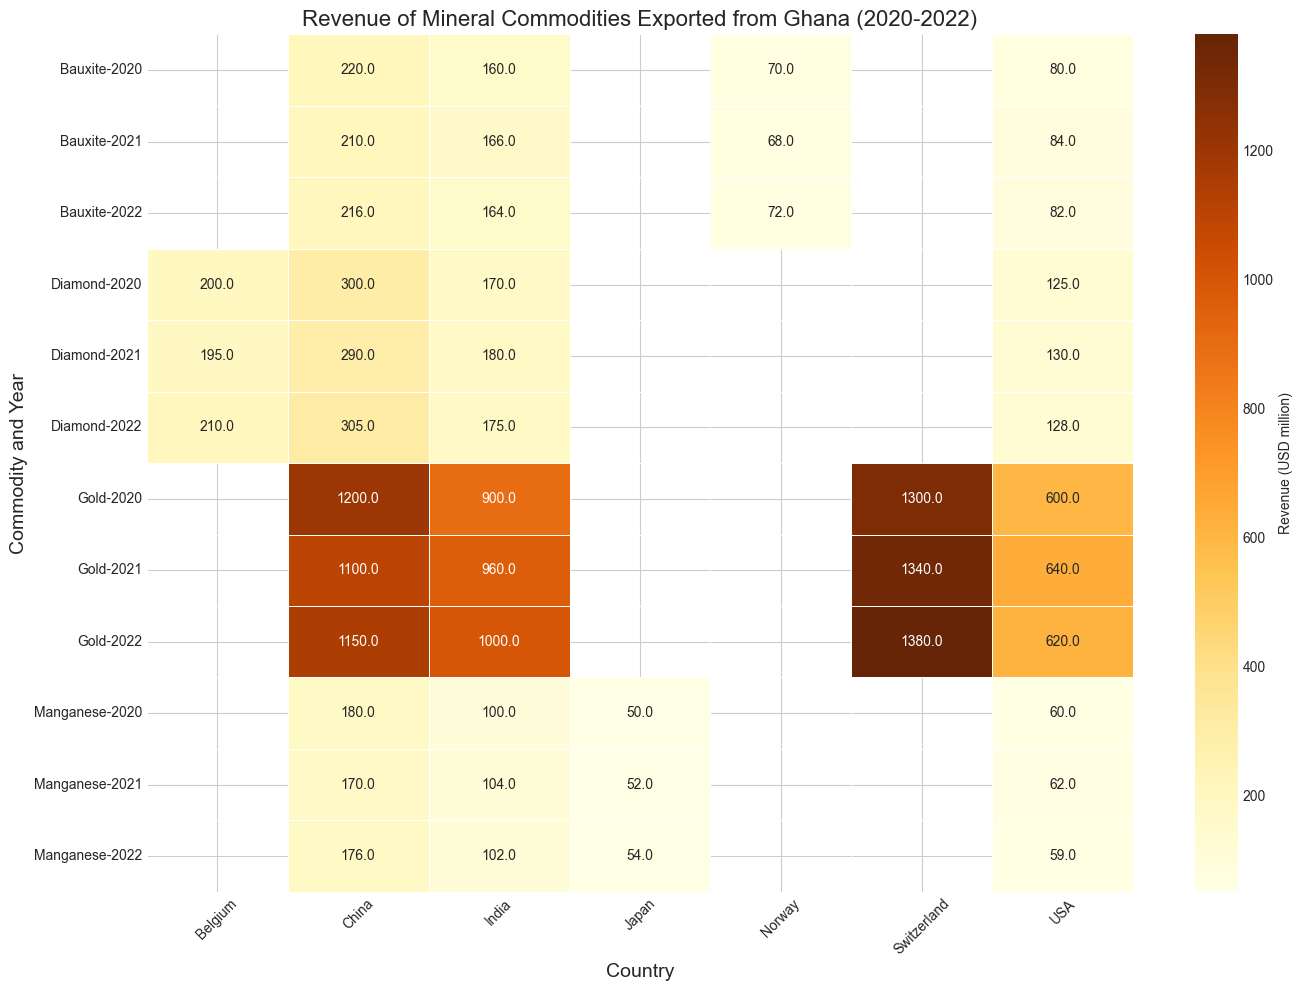What's the revenue for Gold exported to Switzerland in 2021? Locate the cell for "Gold" in the row labeled "2021," and then look under the column for "Switzerland." The value is 1340 (USD million).
Answer: 1340 (USD million) Which country received the highest revenue from Diamond exports in 2022? Locate the row for "Diamond" in the year 2022 and compare the cells under each country. The highest value is 305 (USD million) for China.
Answer: China What is the average revenue from Gold exports to the USA over the three years? Sum the values for Gold exports to the USA (600 + 640 + 620) and divide by the number of years (3). The sum is 1860, and 1860/3 is 620 (USD million).
Answer: 620 (USD million) How does the revenue from Bauxite exports to India in 2020 compare to that in 2022? Locate the cells for Bauxite exports to India in the years 2020 (160 USD million) and 2022 (164 USD million). Compare the values using subtraction: 164 - 160 = 4 (USD million).
Answer: 4 (USD million) more in 2022 Which commodity had the lowest revenue from exports to Norway in 2021? Look under the Norway column and find the lowest value in the year 2021. The lowest value is 68 (USD million) for Bauxite.
Answer: Bauxite How much total revenue was generated from Manganese exports to China over the three years? Sum the values of Manganese exports to China for the years 2020, 2021, and 2022 (180 + 170 + 176), resulting in 526 (USD million).
Answer: 526 (USD million) Does India receive more revenue from Bauxite or Manganese exports in 2022? Compare the values for Bauxite (164 USD million) and Manganese (102 USD million) under the column for India in 2022. Bauxite has a higher value.
Answer: Bauxite What is the difference in revenue from Gold exports to China between 2020 and 2021? Locate the values for Gold exports to China in 2020 (1200 USD million) and 2021 (1100 USD million). The difference is 1200 - 1100 = 100 (USD million).
Answer: 100 (USD million) Which country had a higher revenue from Diamond exports in 2021, USA or Belgium? Locate the values for Diamond exports to the USA (130 USD million) and Belgium (195 USD million) in 2021. Belgium has a higher value.
Answer: Belgium 